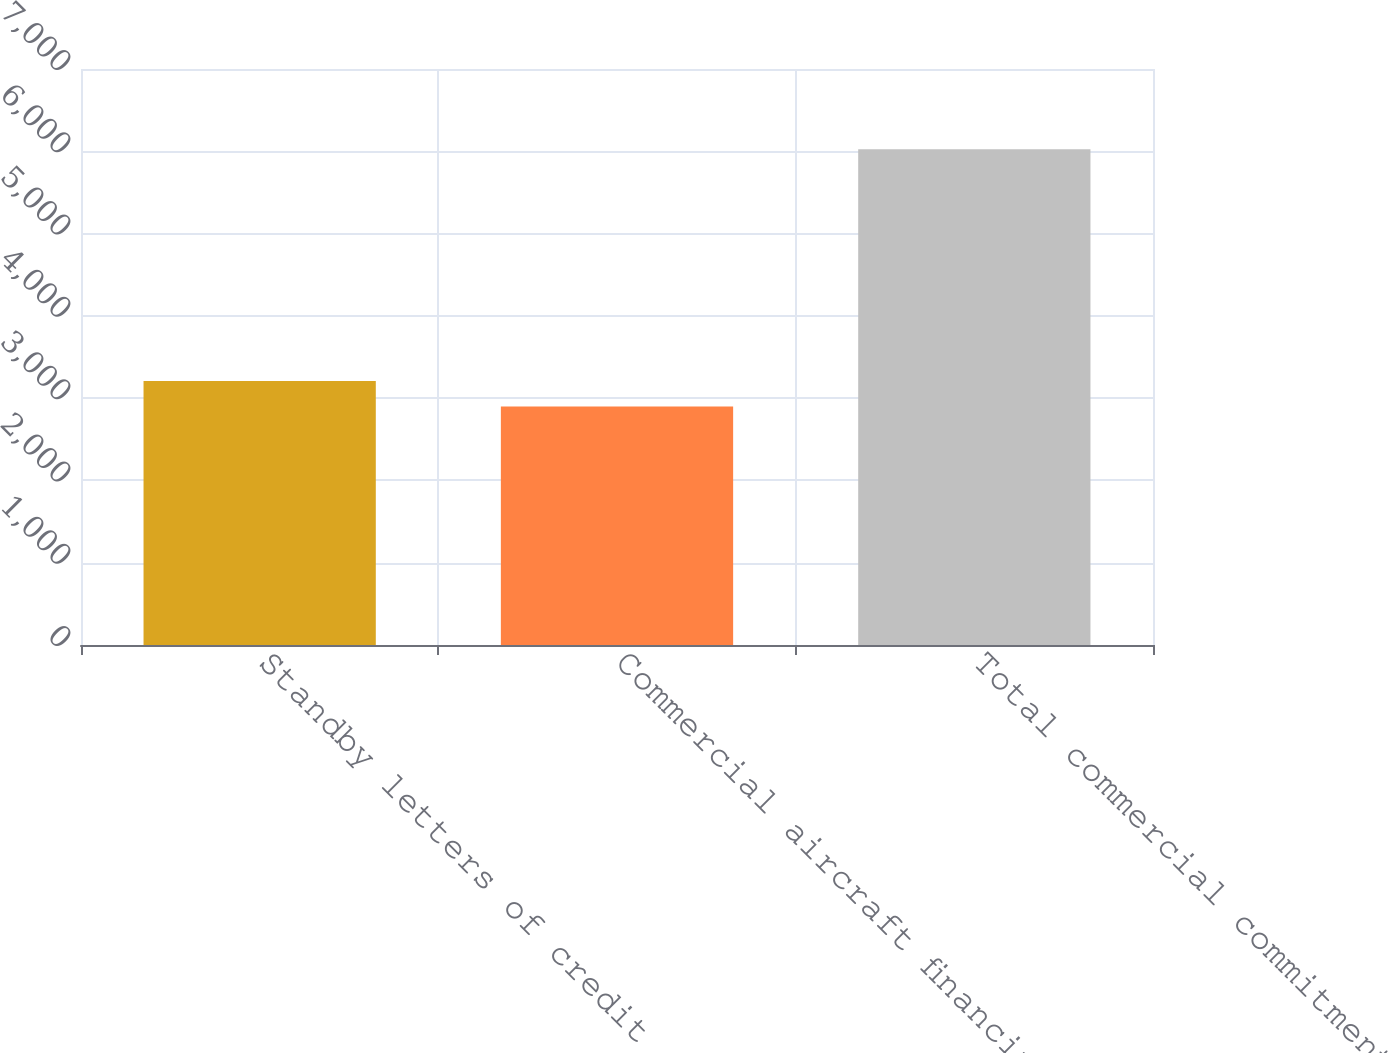Convert chart. <chart><loc_0><loc_0><loc_500><loc_500><bar_chart><fcel>Standby letters of credit and<fcel>Commercial aircraft financing<fcel>Total commercial commitments<nl><fcel>3209.7<fcel>2897<fcel>6024<nl></chart> 